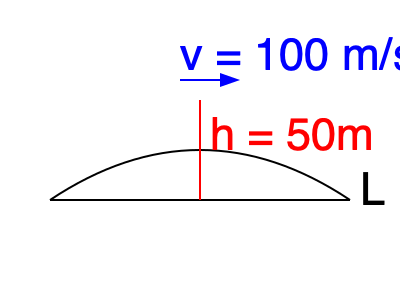An airplane with a wing span of 300 meters is flying at a speed of 100 m/s. The wing can be approximated by a simple airfoil with a maximum height of 50 meters. If the air density is 1.225 kg/m³, calculate the lift force on the wing using the simplified lift equation: $L = \frac{1}{2} \rho v^2 S C_L$, where $C_L \approx \frac{2\pi h}{L}$. Round your answer to the nearest whole number. Let's approach this step-by-step:

1) First, we need to calculate the lift coefficient $C_L$:
   $C_L \approx \frac{2\pi h}{L}$
   where $h = 50$ m and $L = 300$ m
   
   $C_L \approx \frac{2\pi \cdot 50}{300} \approx 1.047$

2) Now we can use the lift equation:
   $L = \frac{1}{2} \rho v^2 S C_L$

   Where:
   $\rho = 1.225$ kg/m³ (air density)
   $v = 100$ m/s (velocity)
   $S = 300$ m (wing span, assuming chord length of 1 m for simplicity)
   $C_L = 1.047$ (calculated above)

3) Let's substitute these values:
   $L = \frac{1}{2} \cdot 1.225 \cdot 100^2 \cdot 300 \cdot 1.047$

4) Calculate:
   $L = 0.5 \cdot 1.225 \cdot 10000 \cdot 300 \cdot 1.047$
   $L = 1,921,327.5$ N

5) Rounding to the nearest whole number:
   $L \approx 1,921,328$ N
Answer: 1,921,328 N 